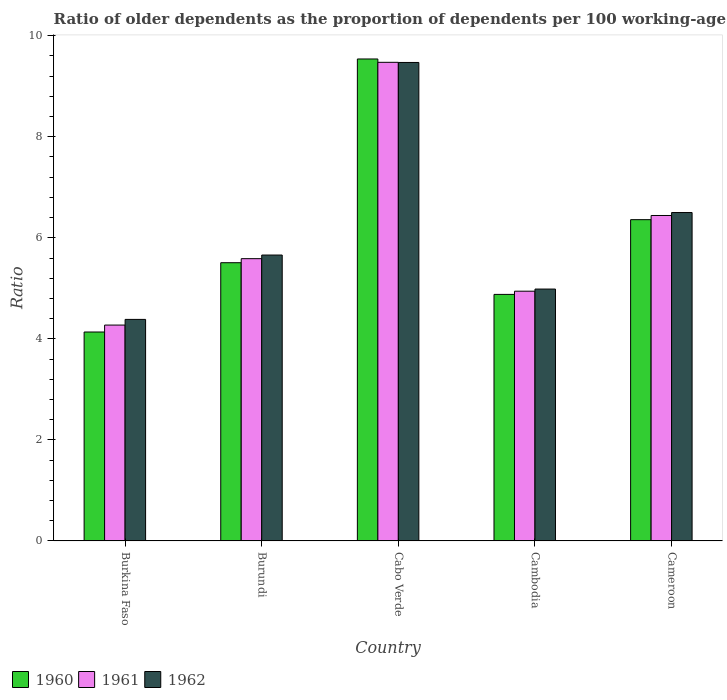Are the number of bars per tick equal to the number of legend labels?
Keep it short and to the point. Yes. What is the label of the 2nd group of bars from the left?
Your answer should be very brief. Burundi. What is the age dependency ratio(old) in 1961 in Cabo Verde?
Keep it short and to the point. 9.47. Across all countries, what is the maximum age dependency ratio(old) in 1962?
Make the answer very short. 9.47. Across all countries, what is the minimum age dependency ratio(old) in 1961?
Make the answer very short. 4.27. In which country was the age dependency ratio(old) in 1961 maximum?
Provide a short and direct response. Cabo Verde. In which country was the age dependency ratio(old) in 1960 minimum?
Provide a short and direct response. Burkina Faso. What is the total age dependency ratio(old) in 1962 in the graph?
Make the answer very short. 31. What is the difference between the age dependency ratio(old) in 1960 in Cabo Verde and that in Cameroon?
Your answer should be very brief. 3.18. What is the difference between the age dependency ratio(old) in 1962 in Cameroon and the age dependency ratio(old) in 1960 in Burkina Faso?
Keep it short and to the point. 2.36. What is the average age dependency ratio(old) in 1961 per country?
Keep it short and to the point. 6.14. What is the difference between the age dependency ratio(old) of/in 1961 and age dependency ratio(old) of/in 1960 in Cabo Verde?
Your answer should be very brief. -0.07. In how many countries, is the age dependency ratio(old) in 1962 greater than 8?
Give a very brief answer. 1. What is the ratio of the age dependency ratio(old) in 1961 in Burundi to that in Cameroon?
Your answer should be very brief. 0.87. Is the difference between the age dependency ratio(old) in 1961 in Cabo Verde and Cambodia greater than the difference between the age dependency ratio(old) in 1960 in Cabo Verde and Cambodia?
Provide a succinct answer. No. What is the difference between the highest and the second highest age dependency ratio(old) in 1962?
Your answer should be very brief. 3.81. What is the difference between the highest and the lowest age dependency ratio(old) in 1960?
Ensure brevity in your answer.  5.4. In how many countries, is the age dependency ratio(old) in 1960 greater than the average age dependency ratio(old) in 1960 taken over all countries?
Your answer should be very brief. 2. How many bars are there?
Your response must be concise. 15. How many countries are there in the graph?
Give a very brief answer. 5. Are the values on the major ticks of Y-axis written in scientific E-notation?
Your response must be concise. No. Does the graph contain any zero values?
Your answer should be very brief. No. Does the graph contain grids?
Give a very brief answer. No. How many legend labels are there?
Give a very brief answer. 3. How are the legend labels stacked?
Offer a very short reply. Horizontal. What is the title of the graph?
Provide a succinct answer. Ratio of older dependents as the proportion of dependents per 100 working-age population. Does "1998" appear as one of the legend labels in the graph?
Provide a short and direct response. No. What is the label or title of the X-axis?
Your response must be concise. Country. What is the label or title of the Y-axis?
Offer a very short reply. Ratio. What is the Ratio of 1960 in Burkina Faso?
Make the answer very short. 4.14. What is the Ratio of 1961 in Burkina Faso?
Offer a terse response. 4.27. What is the Ratio of 1962 in Burkina Faso?
Make the answer very short. 4.39. What is the Ratio in 1960 in Burundi?
Your answer should be very brief. 5.51. What is the Ratio in 1961 in Burundi?
Your answer should be compact. 5.59. What is the Ratio of 1962 in Burundi?
Ensure brevity in your answer.  5.66. What is the Ratio in 1960 in Cabo Verde?
Your response must be concise. 9.54. What is the Ratio of 1961 in Cabo Verde?
Provide a succinct answer. 9.47. What is the Ratio in 1962 in Cabo Verde?
Your response must be concise. 9.47. What is the Ratio of 1960 in Cambodia?
Ensure brevity in your answer.  4.88. What is the Ratio in 1961 in Cambodia?
Keep it short and to the point. 4.94. What is the Ratio of 1962 in Cambodia?
Ensure brevity in your answer.  4.99. What is the Ratio of 1960 in Cameroon?
Provide a short and direct response. 6.36. What is the Ratio of 1961 in Cameroon?
Offer a very short reply. 6.44. What is the Ratio of 1962 in Cameroon?
Provide a short and direct response. 6.5. Across all countries, what is the maximum Ratio in 1960?
Offer a very short reply. 9.54. Across all countries, what is the maximum Ratio of 1961?
Ensure brevity in your answer.  9.47. Across all countries, what is the maximum Ratio of 1962?
Provide a short and direct response. 9.47. Across all countries, what is the minimum Ratio of 1960?
Ensure brevity in your answer.  4.14. Across all countries, what is the minimum Ratio in 1961?
Provide a succinct answer. 4.27. Across all countries, what is the minimum Ratio of 1962?
Make the answer very short. 4.39. What is the total Ratio of 1960 in the graph?
Keep it short and to the point. 30.42. What is the total Ratio in 1961 in the graph?
Your answer should be compact. 30.72. What is the total Ratio of 1962 in the graph?
Your response must be concise. 31. What is the difference between the Ratio in 1960 in Burkina Faso and that in Burundi?
Your answer should be very brief. -1.37. What is the difference between the Ratio in 1961 in Burkina Faso and that in Burundi?
Your answer should be compact. -1.31. What is the difference between the Ratio in 1962 in Burkina Faso and that in Burundi?
Make the answer very short. -1.27. What is the difference between the Ratio in 1960 in Burkina Faso and that in Cabo Verde?
Give a very brief answer. -5.4. What is the difference between the Ratio in 1961 in Burkina Faso and that in Cabo Verde?
Provide a short and direct response. -5.2. What is the difference between the Ratio in 1962 in Burkina Faso and that in Cabo Verde?
Your answer should be compact. -5.09. What is the difference between the Ratio of 1960 in Burkina Faso and that in Cambodia?
Make the answer very short. -0.74. What is the difference between the Ratio in 1961 in Burkina Faso and that in Cambodia?
Your response must be concise. -0.67. What is the difference between the Ratio in 1962 in Burkina Faso and that in Cambodia?
Offer a terse response. -0.6. What is the difference between the Ratio of 1960 in Burkina Faso and that in Cameroon?
Provide a short and direct response. -2.22. What is the difference between the Ratio of 1961 in Burkina Faso and that in Cameroon?
Provide a succinct answer. -2.17. What is the difference between the Ratio of 1962 in Burkina Faso and that in Cameroon?
Ensure brevity in your answer.  -2.12. What is the difference between the Ratio in 1960 in Burundi and that in Cabo Verde?
Ensure brevity in your answer.  -4.03. What is the difference between the Ratio in 1961 in Burundi and that in Cabo Verde?
Your response must be concise. -3.89. What is the difference between the Ratio of 1962 in Burundi and that in Cabo Verde?
Ensure brevity in your answer.  -3.81. What is the difference between the Ratio of 1960 in Burundi and that in Cambodia?
Provide a short and direct response. 0.63. What is the difference between the Ratio in 1961 in Burundi and that in Cambodia?
Your answer should be very brief. 0.64. What is the difference between the Ratio of 1962 in Burundi and that in Cambodia?
Your answer should be very brief. 0.67. What is the difference between the Ratio in 1960 in Burundi and that in Cameroon?
Keep it short and to the point. -0.85. What is the difference between the Ratio of 1961 in Burundi and that in Cameroon?
Your response must be concise. -0.85. What is the difference between the Ratio of 1962 in Burundi and that in Cameroon?
Your answer should be compact. -0.84. What is the difference between the Ratio of 1960 in Cabo Verde and that in Cambodia?
Ensure brevity in your answer.  4.66. What is the difference between the Ratio of 1961 in Cabo Verde and that in Cambodia?
Offer a very short reply. 4.53. What is the difference between the Ratio of 1962 in Cabo Verde and that in Cambodia?
Ensure brevity in your answer.  4.49. What is the difference between the Ratio of 1960 in Cabo Verde and that in Cameroon?
Ensure brevity in your answer.  3.18. What is the difference between the Ratio in 1961 in Cabo Verde and that in Cameroon?
Make the answer very short. 3.03. What is the difference between the Ratio of 1962 in Cabo Verde and that in Cameroon?
Make the answer very short. 2.97. What is the difference between the Ratio of 1960 in Cambodia and that in Cameroon?
Your answer should be very brief. -1.48. What is the difference between the Ratio in 1961 in Cambodia and that in Cameroon?
Provide a short and direct response. -1.5. What is the difference between the Ratio of 1962 in Cambodia and that in Cameroon?
Provide a short and direct response. -1.51. What is the difference between the Ratio in 1960 in Burkina Faso and the Ratio in 1961 in Burundi?
Provide a short and direct response. -1.45. What is the difference between the Ratio of 1960 in Burkina Faso and the Ratio of 1962 in Burundi?
Your answer should be very brief. -1.52. What is the difference between the Ratio in 1961 in Burkina Faso and the Ratio in 1962 in Burundi?
Ensure brevity in your answer.  -1.39. What is the difference between the Ratio of 1960 in Burkina Faso and the Ratio of 1961 in Cabo Verde?
Offer a terse response. -5.34. What is the difference between the Ratio in 1960 in Burkina Faso and the Ratio in 1962 in Cabo Verde?
Ensure brevity in your answer.  -5.34. What is the difference between the Ratio of 1961 in Burkina Faso and the Ratio of 1962 in Cabo Verde?
Make the answer very short. -5.2. What is the difference between the Ratio of 1960 in Burkina Faso and the Ratio of 1961 in Cambodia?
Offer a terse response. -0.81. What is the difference between the Ratio in 1960 in Burkina Faso and the Ratio in 1962 in Cambodia?
Keep it short and to the point. -0.85. What is the difference between the Ratio of 1961 in Burkina Faso and the Ratio of 1962 in Cambodia?
Give a very brief answer. -0.71. What is the difference between the Ratio of 1960 in Burkina Faso and the Ratio of 1961 in Cameroon?
Make the answer very short. -2.31. What is the difference between the Ratio in 1960 in Burkina Faso and the Ratio in 1962 in Cameroon?
Provide a short and direct response. -2.36. What is the difference between the Ratio of 1961 in Burkina Faso and the Ratio of 1962 in Cameroon?
Keep it short and to the point. -2.23. What is the difference between the Ratio in 1960 in Burundi and the Ratio in 1961 in Cabo Verde?
Your answer should be very brief. -3.97. What is the difference between the Ratio of 1960 in Burundi and the Ratio of 1962 in Cabo Verde?
Make the answer very short. -3.96. What is the difference between the Ratio in 1961 in Burundi and the Ratio in 1962 in Cabo Verde?
Offer a very short reply. -3.88. What is the difference between the Ratio of 1960 in Burundi and the Ratio of 1961 in Cambodia?
Provide a short and direct response. 0.56. What is the difference between the Ratio of 1960 in Burundi and the Ratio of 1962 in Cambodia?
Your response must be concise. 0.52. What is the difference between the Ratio of 1961 in Burundi and the Ratio of 1962 in Cambodia?
Your response must be concise. 0.6. What is the difference between the Ratio of 1960 in Burundi and the Ratio of 1961 in Cameroon?
Offer a terse response. -0.93. What is the difference between the Ratio of 1960 in Burundi and the Ratio of 1962 in Cameroon?
Keep it short and to the point. -0.99. What is the difference between the Ratio in 1961 in Burundi and the Ratio in 1962 in Cameroon?
Your answer should be compact. -0.91. What is the difference between the Ratio of 1960 in Cabo Verde and the Ratio of 1961 in Cambodia?
Provide a short and direct response. 4.6. What is the difference between the Ratio in 1960 in Cabo Verde and the Ratio in 1962 in Cambodia?
Offer a very short reply. 4.55. What is the difference between the Ratio of 1961 in Cabo Verde and the Ratio of 1962 in Cambodia?
Your response must be concise. 4.49. What is the difference between the Ratio of 1960 in Cabo Verde and the Ratio of 1961 in Cameroon?
Provide a succinct answer. 3.1. What is the difference between the Ratio in 1960 in Cabo Verde and the Ratio in 1962 in Cameroon?
Offer a very short reply. 3.04. What is the difference between the Ratio in 1961 in Cabo Verde and the Ratio in 1962 in Cameroon?
Offer a very short reply. 2.97. What is the difference between the Ratio of 1960 in Cambodia and the Ratio of 1961 in Cameroon?
Your answer should be very brief. -1.56. What is the difference between the Ratio in 1960 in Cambodia and the Ratio in 1962 in Cameroon?
Give a very brief answer. -1.62. What is the difference between the Ratio in 1961 in Cambodia and the Ratio in 1962 in Cameroon?
Your answer should be compact. -1.56. What is the average Ratio in 1960 per country?
Provide a short and direct response. 6.08. What is the average Ratio in 1961 per country?
Make the answer very short. 6.14. What is the average Ratio of 1962 per country?
Make the answer very short. 6.2. What is the difference between the Ratio in 1960 and Ratio in 1961 in Burkina Faso?
Give a very brief answer. -0.14. What is the difference between the Ratio in 1960 and Ratio in 1962 in Burkina Faso?
Ensure brevity in your answer.  -0.25. What is the difference between the Ratio in 1961 and Ratio in 1962 in Burkina Faso?
Provide a short and direct response. -0.11. What is the difference between the Ratio in 1960 and Ratio in 1961 in Burundi?
Give a very brief answer. -0.08. What is the difference between the Ratio of 1960 and Ratio of 1962 in Burundi?
Offer a very short reply. -0.15. What is the difference between the Ratio in 1961 and Ratio in 1962 in Burundi?
Offer a terse response. -0.07. What is the difference between the Ratio in 1960 and Ratio in 1961 in Cabo Verde?
Ensure brevity in your answer.  0.07. What is the difference between the Ratio of 1960 and Ratio of 1962 in Cabo Verde?
Offer a very short reply. 0.07. What is the difference between the Ratio in 1961 and Ratio in 1962 in Cabo Verde?
Provide a short and direct response. 0. What is the difference between the Ratio of 1960 and Ratio of 1961 in Cambodia?
Your answer should be very brief. -0.06. What is the difference between the Ratio in 1960 and Ratio in 1962 in Cambodia?
Ensure brevity in your answer.  -0.11. What is the difference between the Ratio in 1961 and Ratio in 1962 in Cambodia?
Make the answer very short. -0.04. What is the difference between the Ratio of 1960 and Ratio of 1961 in Cameroon?
Offer a very short reply. -0.08. What is the difference between the Ratio of 1960 and Ratio of 1962 in Cameroon?
Your answer should be very brief. -0.14. What is the difference between the Ratio of 1961 and Ratio of 1962 in Cameroon?
Offer a terse response. -0.06. What is the ratio of the Ratio in 1960 in Burkina Faso to that in Burundi?
Offer a very short reply. 0.75. What is the ratio of the Ratio of 1961 in Burkina Faso to that in Burundi?
Give a very brief answer. 0.76. What is the ratio of the Ratio in 1962 in Burkina Faso to that in Burundi?
Offer a very short reply. 0.77. What is the ratio of the Ratio in 1960 in Burkina Faso to that in Cabo Verde?
Give a very brief answer. 0.43. What is the ratio of the Ratio in 1961 in Burkina Faso to that in Cabo Verde?
Your answer should be very brief. 0.45. What is the ratio of the Ratio of 1962 in Burkina Faso to that in Cabo Verde?
Offer a very short reply. 0.46. What is the ratio of the Ratio of 1960 in Burkina Faso to that in Cambodia?
Make the answer very short. 0.85. What is the ratio of the Ratio of 1961 in Burkina Faso to that in Cambodia?
Provide a succinct answer. 0.86. What is the ratio of the Ratio in 1962 in Burkina Faso to that in Cambodia?
Your response must be concise. 0.88. What is the ratio of the Ratio of 1960 in Burkina Faso to that in Cameroon?
Provide a short and direct response. 0.65. What is the ratio of the Ratio in 1961 in Burkina Faso to that in Cameroon?
Offer a very short reply. 0.66. What is the ratio of the Ratio of 1962 in Burkina Faso to that in Cameroon?
Offer a very short reply. 0.67. What is the ratio of the Ratio in 1960 in Burundi to that in Cabo Verde?
Offer a very short reply. 0.58. What is the ratio of the Ratio of 1961 in Burundi to that in Cabo Verde?
Provide a succinct answer. 0.59. What is the ratio of the Ratio in 1962 in Burundi to that in Cabo Verde?
Offer a very short reply. 0.6. What is the ratio of the Ratio in 1960 in Burundi to that in Cambodia?
Ensure brevity in your answer.  1.13. What is the ratio of the Ratio of 1961 in Burundi to that in Cambodia?
Ensure brevity in your answer.  1.13. What is the ratio of the Ratio in 1962 in Burundi to that in Cambodia?
Give a very brief answer. 1.14. What is the ratio of the Ratio in 1960 in Burundi to that in Cameroon?
Give a very brief answer. 0.87. What is the ratio of the Ratio in 1961 in Burundi to that in Cameroon?
Keep it short and to the point. 0.87. What is the ratio of the Ratio of 1962 in Burundi to that in Cameroon?
Offer a very short reply. 0.87. What is the ratio of the Ratio of 1960 in Cabo Verde to that in Cambodia?
Offer a very short reply. 1.95. What is the ratio of the Ratio in 1961 in Cabo Verde to that in Cambodia?
Keep it short and to the point. 1.92. What is the ratio of the Ratio of 1962 in Cabo Verde to that in Cambodia?
Offer a very short reply. 1.9. What is the ratio of the Ratio in 1960 in Cabo Verde to that in Cameroon?
Your response must be concise. 1.5. What is the ratio of the Ratio in 1961 in Cabo Verde to that in Cameroon?
Offer a terse response. 1.47. What is the ratio of the Ratio of 1962 in Cabo Verde to that in Cameroon?
Offer a terse response. 1.46. What is the ratio of the Ratio in 1960 in Cambodia to that in Cameroon?
Provide a succinct answer. 0.77. What is the ratio of the Ratio in 1961 in Cambodia to that in Cameroon?
Offer a very short reply. 0.77. What is the ratio of the Ratio in 1962 in Cambodia to that in Cameroon?
Make the answer very short. 0.77. What is the difference between the highest and the second highest Ratio in 1960?
Your response must be concise. 3.18. What is the difference between the highest and the second highest Ratio of 1961?
Make the answer very short. 3.03. What is the difference between the highest and the second highest Ratio in 1962?
Your response must be concise. 2.97. What is the difference between the highest and the lowest Ratio of 1960?
Offer a terse response. 5.4. What is the difference between the highest and the lowest Ratio in 1961?
Give a very brief answer. 5.2. What is the difference between the highest and the lowest Ratio in 1962?
Offer a terse response. 5.09. 